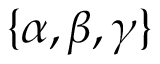Convert formula to latex. <formula><loc_0><loc_0><loc_500><loc_500>\{ \alpha , \beta , \gamma \}</formula> 